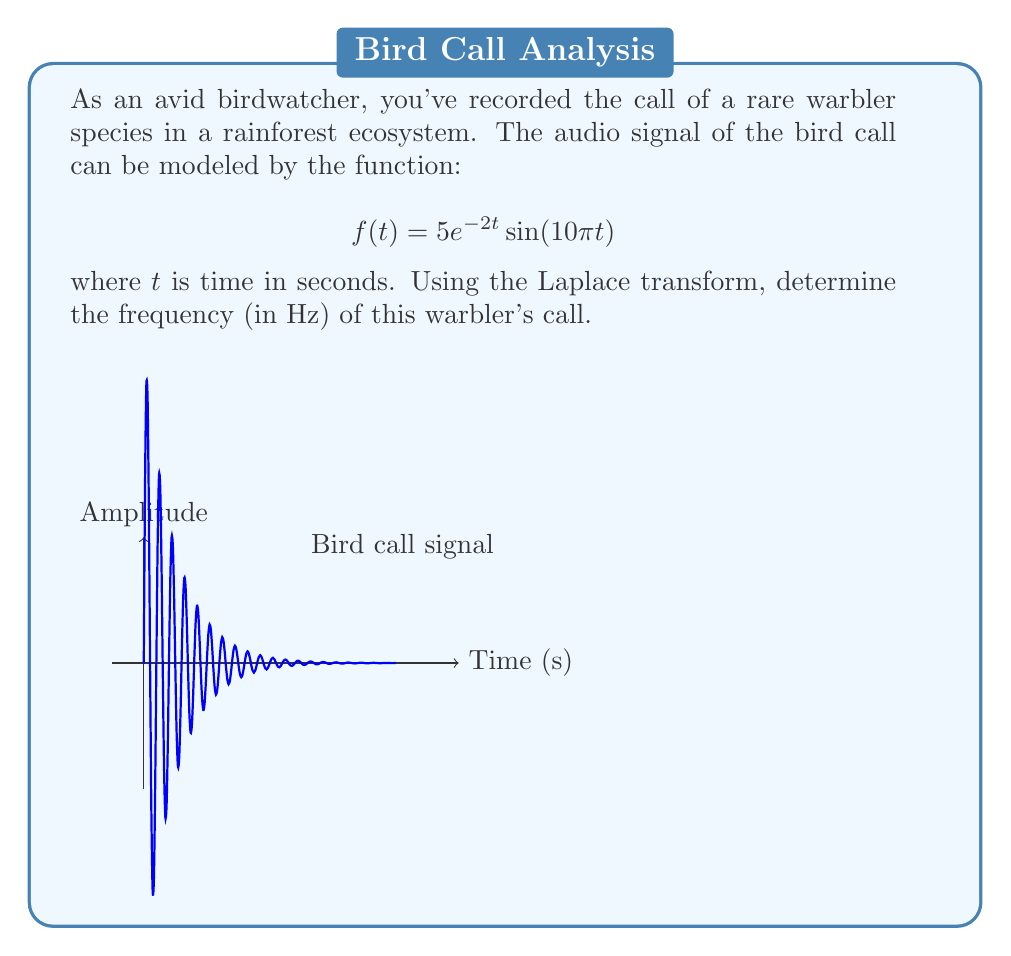Provide a solution to this math problem. Let's approach this step-by-step:

1) The Laplace transform of $f(t) = 5e^{-2t}\sin(10\pi t)$ is given by:

   $$F(s) = \mathcal{L}\{f(t)\} = \frac{5(10\pi)}{(s+2)^2 + (10\pi)^2}$$

2) In the Laplace domain, the imaginary part of the complex poles represents the angular frequency of the sinusoidal component. The poles are the roots of the denominator:

   $$(s+2)^2 + (10\pi)^2 = 0$$

3) Solving this equation:

   $$s = -2 \pm 10\pi i$$

4) The imaginary part of the poles is $\pm 10\pi$. This represents the angular frequency $\omega$ in radians per second.

5) To convert angular frequency to frequency in Hz, we use the formula:

   $$f = \frac{\omega}{2\pi}$$

6) Substituting $\omega = 10\pi$:

   $$f = \frac{10\pi}{2\pi} = 5\text{ Hz}$$

Therefore, the frequency of the warbler's call is 5 Hz.
Answer: 5 Hz 